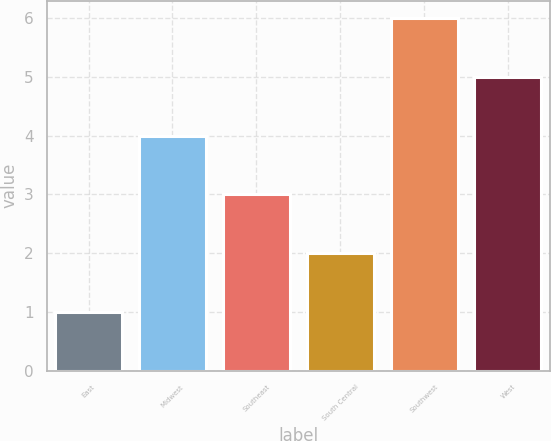<chart> <loc_0><loc_0><loc_500><loc_500><bar_chart><fcel>East<fcel>Midwest<fcel>Southeast<fcel>South Central<fcel>Southwest<fcel>West<nl><fcel>1<fcel>4<fcel>3<fcel>2<fcel>6<fcel>5<nl></chart> 